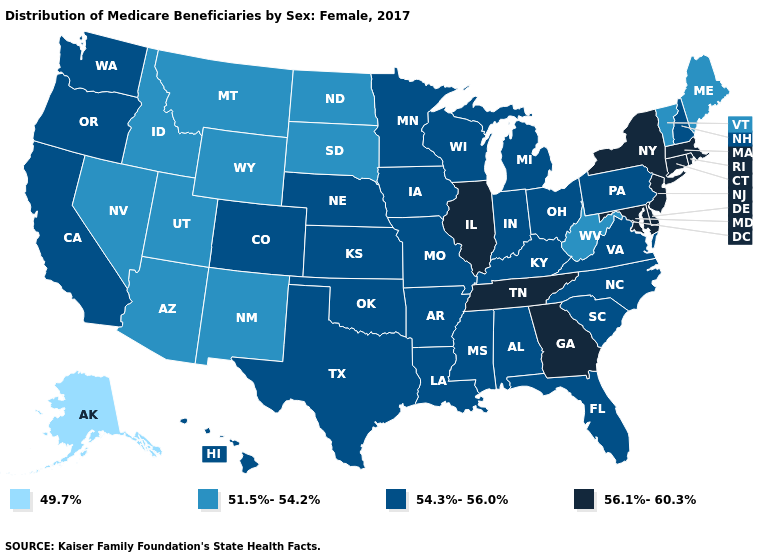Among the states that border New York , which have the highest value?
Answer briefly. Connecticut, Massachusetts, New Jersey. Does Hawaii have a higher value than Ohio?
Quick response, please. No. Among the states that border Montana , which have the lowest value?
Concise answer only. Idaho, North Dakota, South Dakota, Wyoming. Is the legend a continuous bar?
Short answer required. No. Does Vermont have a higher value than Alaska?
Keep it brief. Yes. What is the highest value in the South ?
Give a very brief answer. 56.1%-60.3%. Which states hav the highest value in the West?
Write a very short answer. California, Colorado, Hawaii, Oregon, Washington. Name the states that have a value in the range 49.7%?
Keep it brief. Alaska. What is the value of Massachusetts?
Short answer required. 56.1%-60.3%. Name the states that have a value in the range 54.3%-56.0%?
Answer briefly. Alabama, Arkansas, California, Colorado, Florida, Hawaii, Indiana, Iowa, Kansas, Kentucky, Louisiana, Michigan, Minnesota, Mississippi, Missouri, Nebraska, New Hampshire, North Carolina, Ohio, Oklahoma, Oregon, Pennsylvania, South Carolina, Texas, Virginia, Washington, Wisconsin. What is the value of Minnesota?
Short answer required. 54.3%-56.0%. Does Alaska have the lowest value in the USA?
Short answer required. Yes. What is the highest value in the USA?
Quick response, please. 56.1%-60.3%. Name the states that have a value in the range 56.1%-60.3%?
Keep it brief. Connecticut, Delaware, Georgia, Illinois, Maryland, Massachusetts, New Jersey, New York, Rhode Island, Tennessee. What is the value of Wisconsin?
Answer briefly. 54.3%-56.0%. 